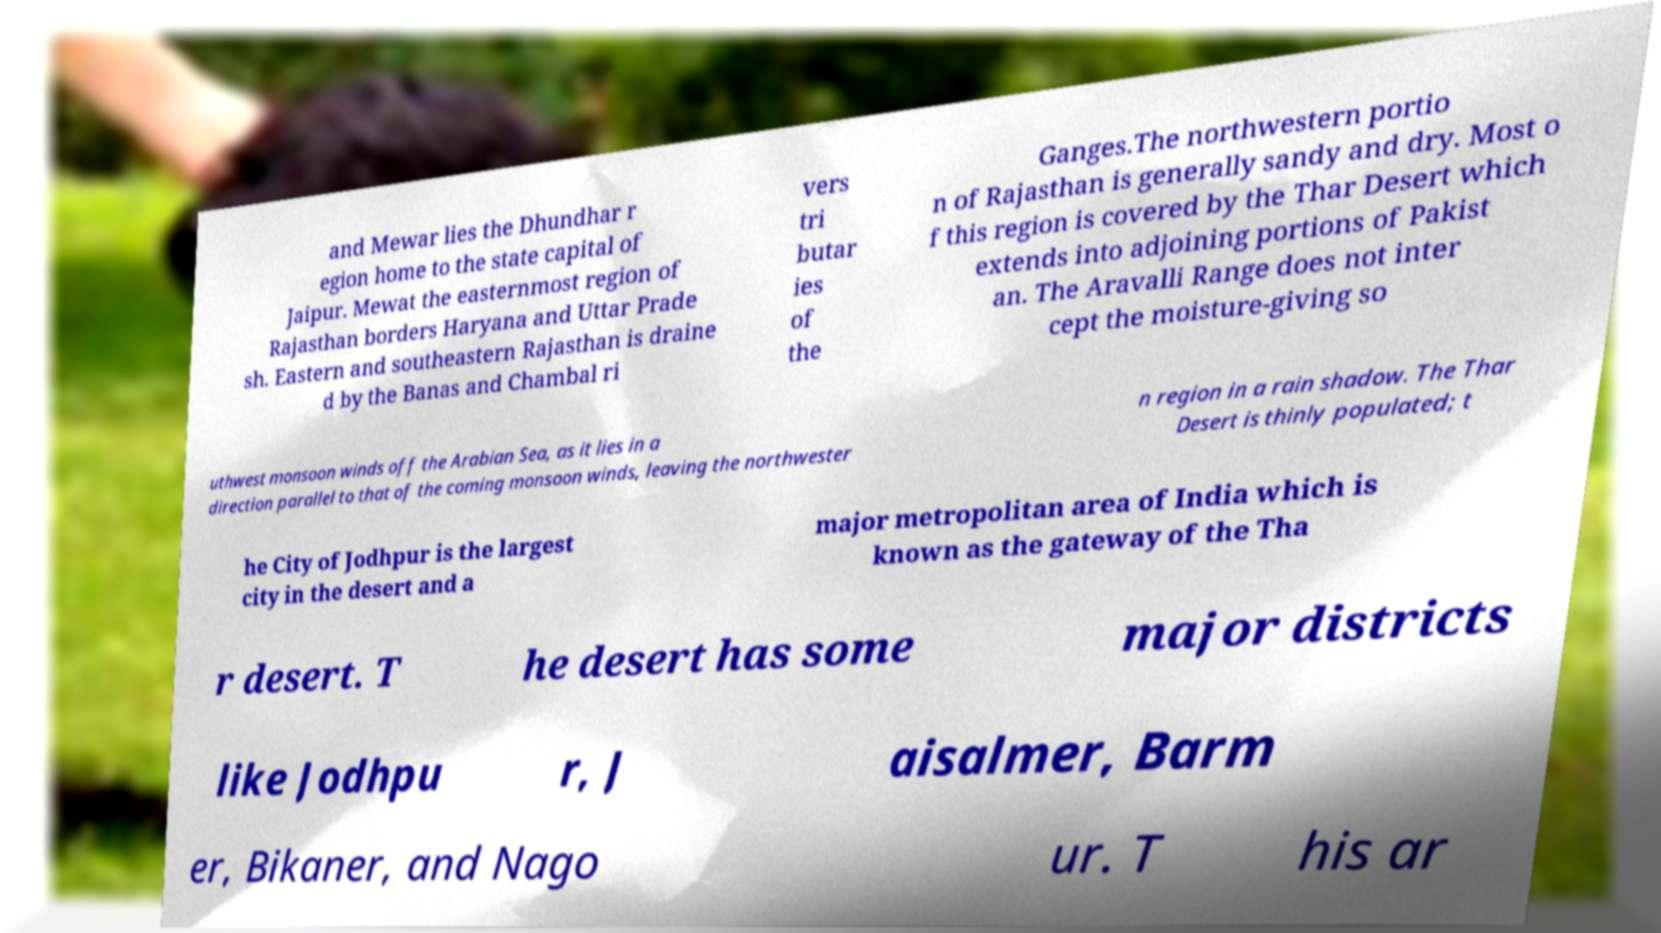Can you accurately transcribe the text from the provided image for me? and Mewar lies the Dhundhar r egion home to the state capital of Jaipur. Mewat the easternmost region of Rajasthan borders Haryana and Uttar Prade sh. Eastern and southeastern Rajasthan is draine d by the Banas and Chambal ri vers tri butar ies of the Ganges.The northwestern portio n of Rajasthan is generally sandy and dry. Most o f this region is covered by the Thar Desert which extends into adjoining portions of Pakist an. The Aravalli Range does not inter cept the moisture-giving so uthwest monsoon winds off the Arabian Sea, as it lies in a direction parallel to that of the coming monsoon winds, leaving the northwester n region in a rain shadow. The Thar Desert is thinly populated; t he City of Jodhpur is the largest city in the desert and a major metropolitan area of India which is known as the gateway of the Tha r desert. T he desert has some major districts like Jodhpu r, J aisalmer, Barm er, Bikaner, and Nago ur. T his ar 